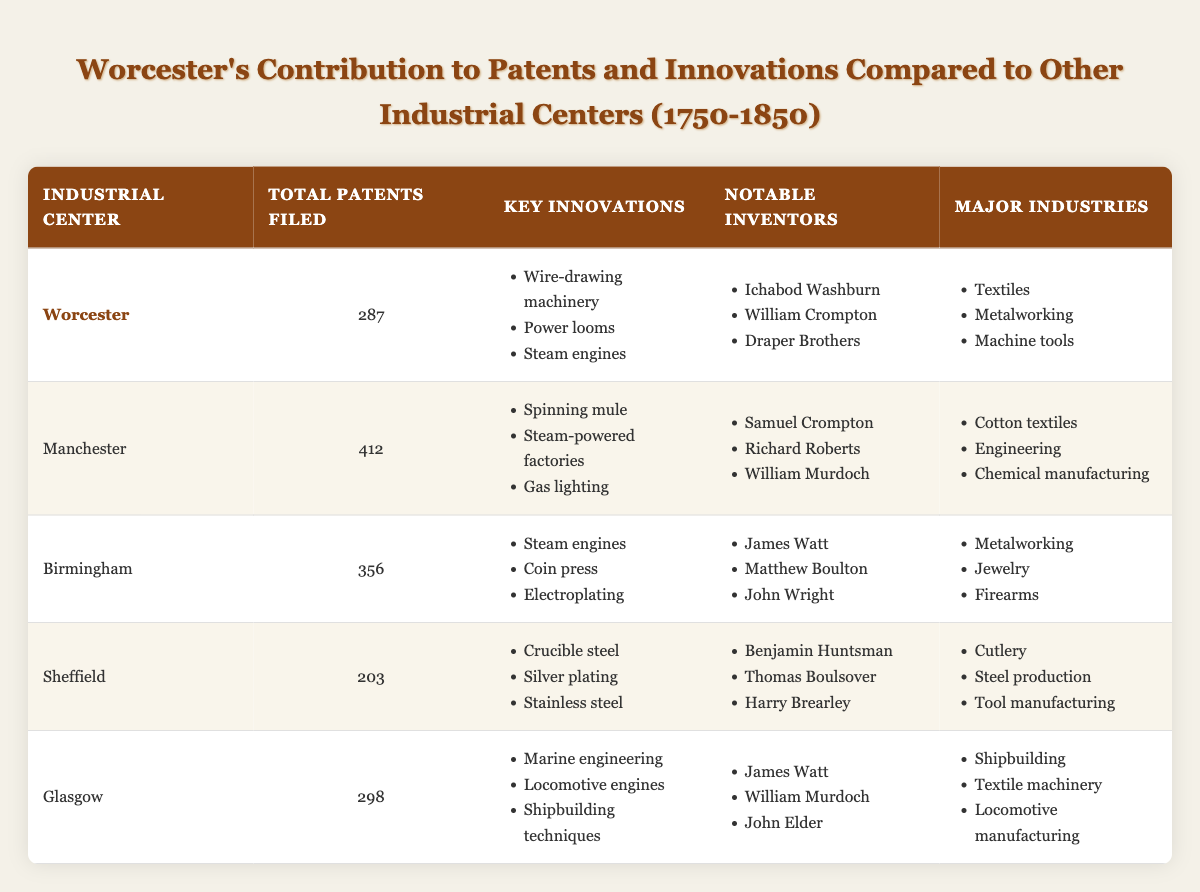What is the total number of patents filed by Worcester? According to the table, Worcester has a total of 287 patents filed under the "Total Patents Filed" column.
Answer: 287 Which industrial center filed the most patents? By comparing the "Total Patents Filed" for each listed industrial center, Manchester has 412 patents, which is higher than all other centers.
Answer: Manchester Is it true that Birmingham has more patents filed than Sheffield? Birmingham has 356 patents filed while Sheffield has only 203 patents filed, confirming that Birmingham has more patents.
Answer: Yes What are the key innovations of Worcester? The key innovations listed for Worcester are wire-drawing machinery, power looms, and steam engines, which can be found in the "Key Innovations" column.
Answer: Wire-drawing machinery, power looms, steam engines What is the difference in total patents filed between Worcester and Glasgow? Worcester has 287 patents, and Glasgow has 298 patents. The difference is calculated as 298 - 287 = 11.
Answer: 11 Which industrial center had notable inventors including James Watt? The table shows that both Birmingham and Glasgow list James Watt as a notable inventor under the "Notable Inventors" column.
Answer: Birmingham, Glasgow On average, how many patents were filed by the centers listed in the table? First, add all the patents filed: (287 + 412 + 356 + 203 + 298) = 1556. There are five centers, so the average is 1556 / 5 = 311.2.
Answer: 311.2 Which center has the lowest total patents filed and what is that number? The total patents filed are least for Sheffield, as it has only 203 patents, identified in the "Total Patents Filed" column.
Answer: 203 Do notable inventors from Worcester work in the textile industry? The notable inventors listed for Worcester include Ichabod Washburn, William Crompton, and Draper Brothers, and the major industries include textiles, confirming their involvement in textiles.
Answer: Yes 